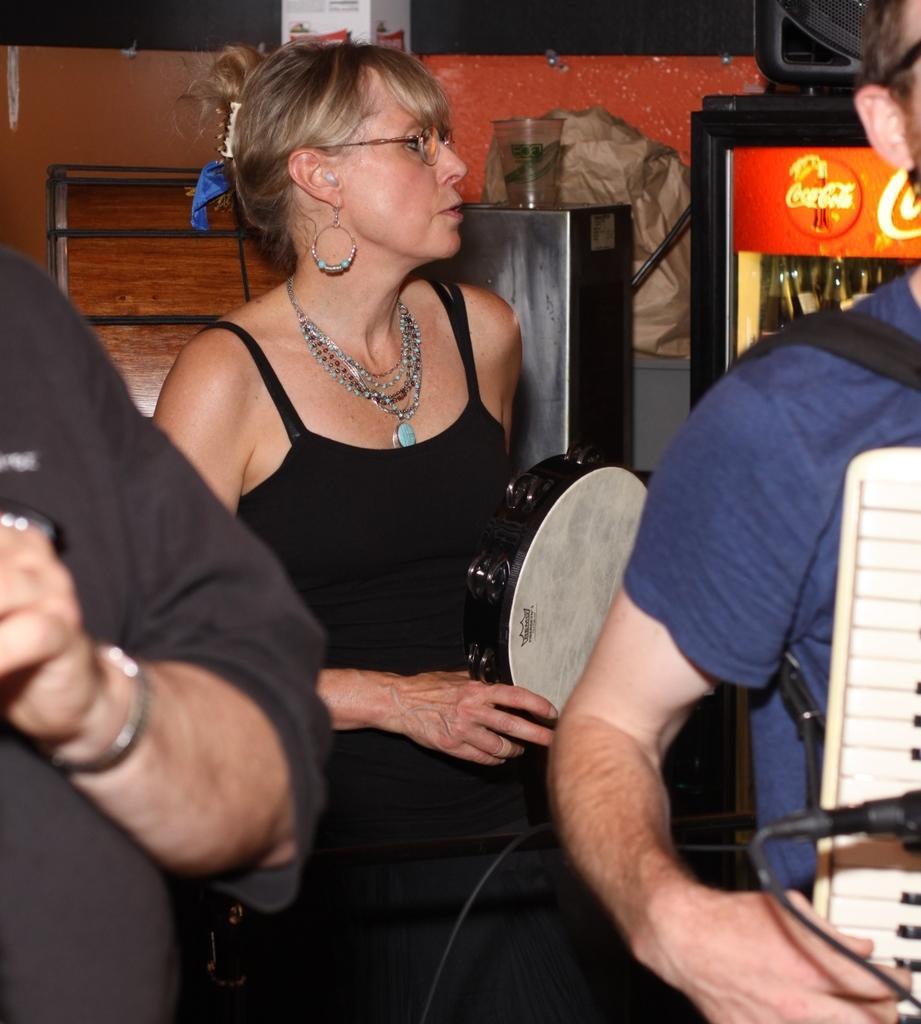In one or two sentences, can you explain what this image depicts? In this picture we can see three persons were a woman holding a musical instrument with her hand and beside to her a man holding a piano with his hand and in the background we can see a glass, refrigerator. 